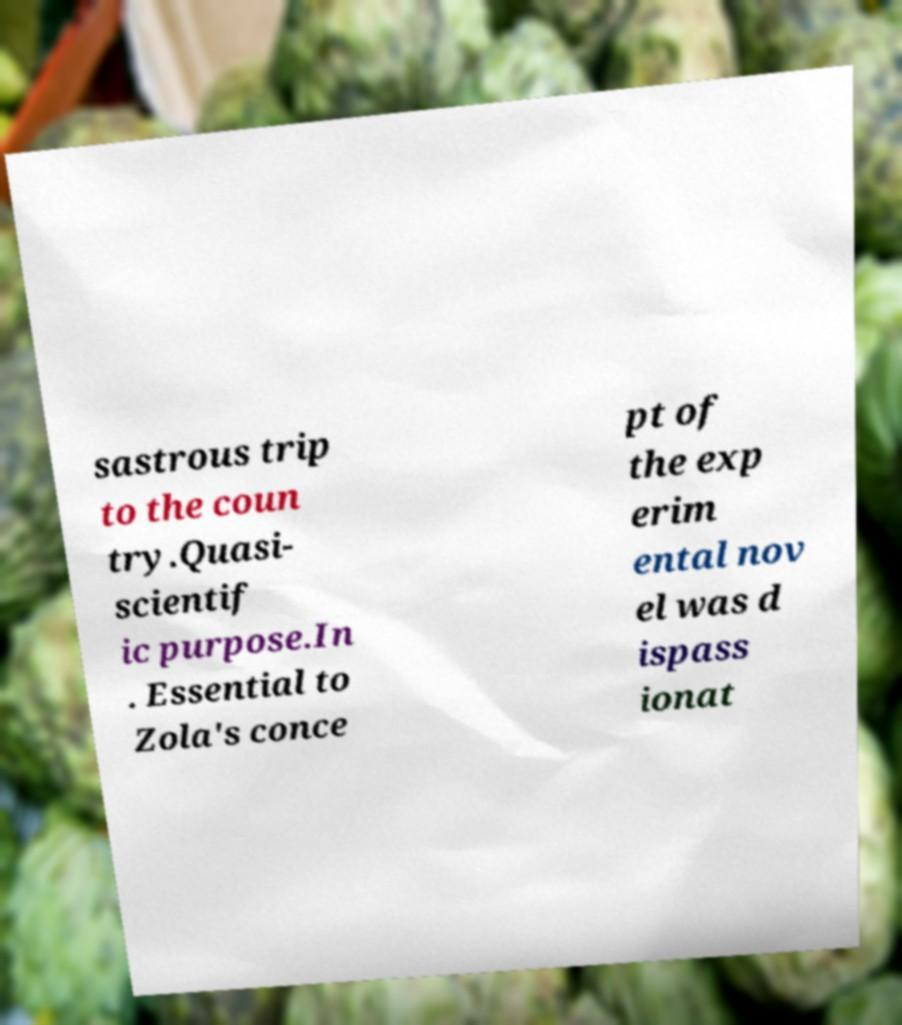Could you assist in decoding the text presented in this image and type it out clearly? sastrous trip to the coun try.Quasi- scientif ic purpose.In . Essential to Zola's conce pt of the exp erim ental nov el was d ispass ionat 